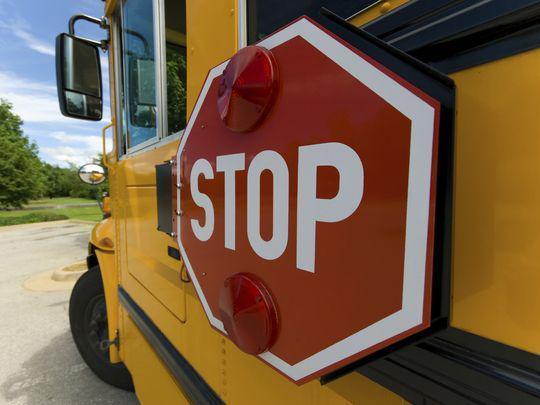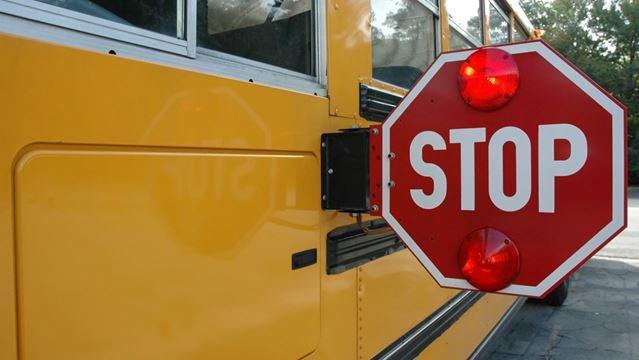The first image is the image on the left, the second image is the image on the right. Analyze the images presented: Is the assertion "Exactly two stop signs are extended." valid? Answer yes or no. No. The first image is the image on the left, the second image is the image on the right. Analyze the images presented: Is the assertion "Each image includes a red octagonal sign with a word between two red lights on the top and bottom, and in one image, the top light appears illuminated." valid? Answer yes or no. Yes. 